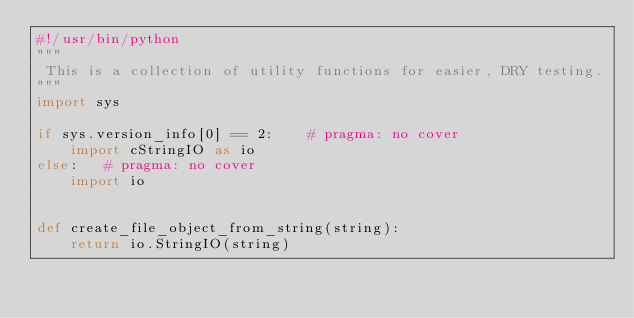<code> <loc_0><loc_0><loc_500><loc_500><_Python_>#!/usr/bin/python
"""
 This is a collection of utility functions for easier, DRY testing.
"""
import sys

if sys.version_info[0] == 2:    # pragma: no cover
    import cStringIO as io
else:   # pragma: no cover
    import io


def create_file_object_from_string(string):
    return io.StringIO(string)
</code> 